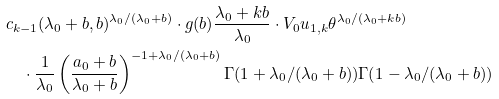<formula> <loc_0><loc_0><loc_500><loc_500>& c _ { k - 1 } ( \lambda _ { 0 } + b , b ) ^ { \lambda _ { 0 } / ( \lambda _ { 0 } + b ) } \cdot g ( b ) \frac { \lambda _ { 0 } + k b } { \lambda _ { 0 } } \cdot V _ { 0 } u _ { 1 , k } \theta ^ { \lambda _ { 0 } / ( \lambda _ { 0 } + k b ) } \\ & \quad \cdot \frac { 1 } { \lambda _ { 0 } } \left ( \frac { a _ { 0 } + b } { \lambda _ { 0 } + b } \right ) ^ { - 1 + \lambda _ { 0 } / ( \lambda _ { 0 } + b ) } \Gamma ( 1 + \lambda _ { 0 } / ( \lambda _ { 0 } + b ) ) \Gamma ( 1 - \lambda _ { 0 } / ( \lambda _ { 0 } + b ) )</formula> 